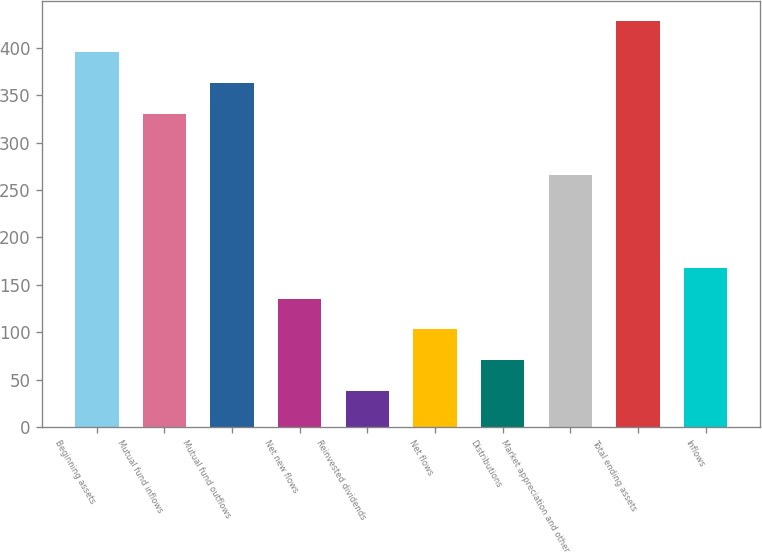Convert chart to OTSL. <chart><loc_0><loc_0><loc_500><loc_500><bar_chart><fcel>Beginning assets<fcel>Mutual fund inflows<fcel>Mutual fund outflows<fcel>Net new flows<fcel>Reinvested dividends<fcel>Net flows<fcel>Distributions<fcel>Market appreciation and other<fcel>Total ending assets<fcel>Inflows<nl><fcel>395.36<fcel>330.4<fcel>362.88<fcel>135.52<fcel>38.08<fcel>103.04<fcel>70.56<fcel>265.44<fcel>427.84<fcel>168<nl></chart> 